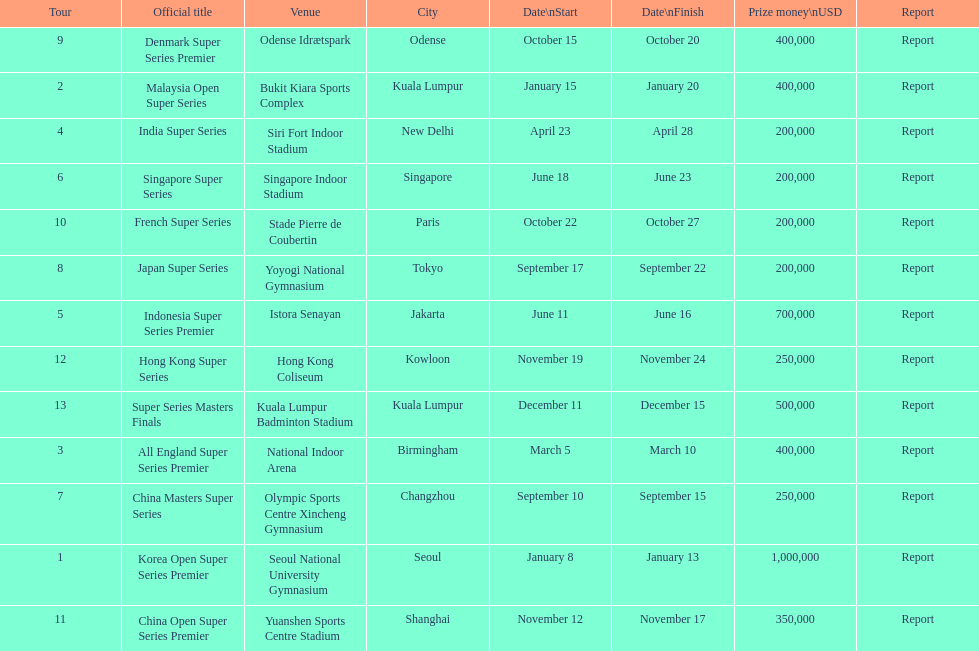Which tour was the only one to take place in december? Super Series Masters Finals. 